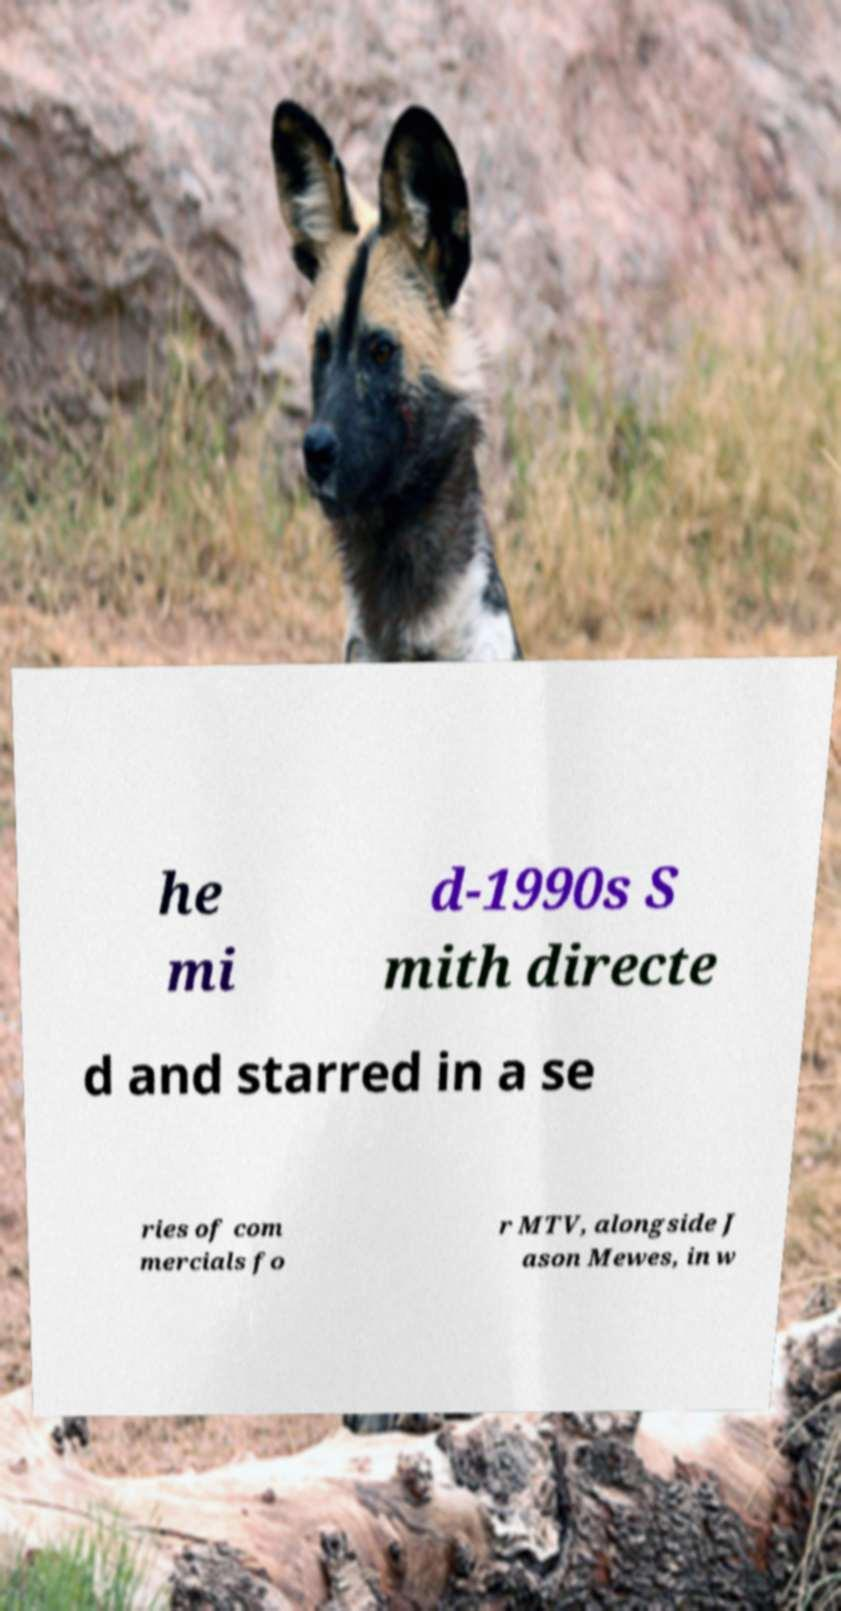I need the written content from this picture converted into text. Can you do that? he mi d-1990s S mith directe d and starred in a se ries of com mercials fo r MTV, alongside J ason Mewes, in w 